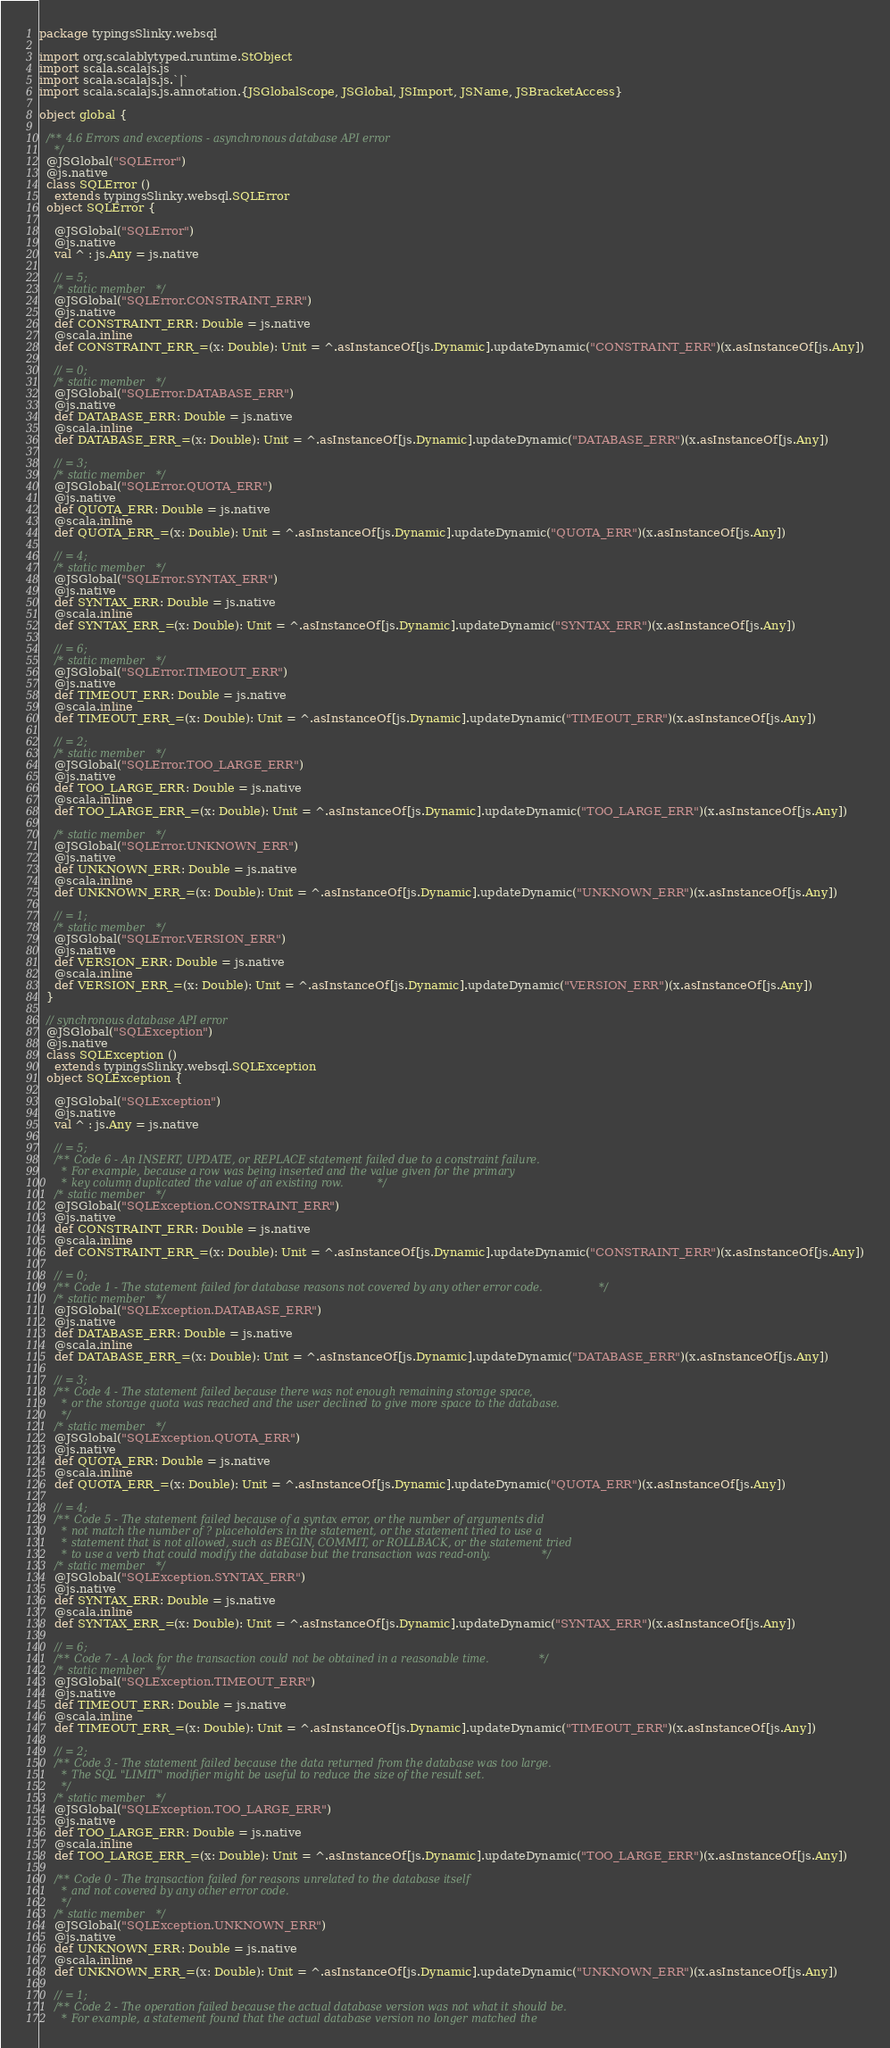Convert code to text. <code><loc_0><loc_0><loc_500><loc_500><_Scala_>package typingsSlinky.websql

import org.scalablytyped.runtime.StObject
import scala.scalajs.js
import scala.scalajs.js.`|`
import scala.scalajs.js.annotation.{JSGlobalScope, JSGlobal, JSImport, JSName, JSBracketAccess}

object global {
  
  /** 4.6 Errors and exceptions - asynchronous database API error
    */
  @JSGlobal("SQLError")
  @js.native
  class SQLError ()
    extends typingsSlinky.websql.SQLError
  object SQLError {
    
    @JSGlobal("SQLError")
    @js.native
    val ^ : js.Any = js.native
    
    // = 5;
    /* static member */
    @JSGlobal("SQLError.CONSTRAINT_ERR")
    @js.native
    def CONSTRAINT_ERR: Double = js.native
    @scala.inline
    def CONSTRAINT_ERR_=(x: Double): Unit = ^.asInstanceOf[js.Dynamic].updateDynamic("CONSTRAINT_ERR")(x.asInstanceOf[js.Any])
    
    // = 0;
    /* static member */
    @JSGlobal("SQLError.DATABASE_ERR")
    @js.native
    def DATABASE_ERR: Double = js.native
    @scala.inline
    def DATABASE_ERR_=(x: Double): Unit = ^.asInstanceOf[js.Dynamic].updateDynamic("DATABASE_ERR")(x.asInstanceOf[js.Any])
    
    // = 3;
    /* static member */
    @JSGlobal("SQLError.QUOTA_ERR")
    @js.native
    def QUOTA_ERR: Double = js.native
    @scala.inline
    def QUOTA_ERR_=(x: Double): Unit = ^.asInstanceOf[js.Dynamic].updateDynamic("QUOTA_ERR")(x.asInstanceOf[js.Any])
    
    // = 4;
    /* static member */
    @JSGlobal("SQLError.SYNTAX_ERR")
    @js.native
    def SYNTAX_ERR: Double = js.native
    @scala.inline
    def SYNTAX_ERR_=(x: Double): Unit = ^.asInstanceOf[js.Dynamic].updateDynamic("SYNTAX_ERR")(x.asInstanceOf[js.Any])
    
    // = 6;
    /* static member */
    @JSGlobal("SQLError.TIMEOUT_ERR")
    @js.native
    def TIMEOUT_ERR: Double = js.native
    @scala.inline
    def TIMEOUT_ERR_=(x: Double): Unit = ^.asInstanceOf[js.Dynamic].updateDynamic("TIMEOUT_ERR")(x.asInstanceOf[js.Any])
    
    // = 2;
    /* static member */
    @JSGlobal("SQLError.TOO_LARGE_ERR")
    @js.native
    def TOO_LARGE_ERR: Double = js.native
    @scala.inline
    def TOO_LARGE_ERR_=(x: Double): Unit = ^.asInstanceOf[js.Dynamic].updateDynamic("TOO_LARGE_ERR")(x.asInstanceOf[js.Any])
    
    /* static member */
    @JSGlobal("SQLError.UNKNOWN_ERR")
    @js.native
    def UNKNOWN_ERR: Double = js.native
    @scala.inline
    def UNKNOWN_ERR_=(x: Double): Unit = ^.asInstanceOf[js.Dynamic].updateDynamic("UNKNOWN_ERR")(x.asInstanceOf[js.Any])
    
    // = 1;
    /* static member */
    @JSGlobal("SQLError.VERSION_ERR")
    @js.native
    def VERSION_ERR: Double = js.native
    @scala.inline
    def VERSION_ERR_=(x: Double): Unit = ^.asInstanceOf[js.Dynamic].updateDynamic("VERSION_ERR")(x.asInstanceOf[js.Any])
  }
  
  // synchronous database API error
  @JSGlobal("SQLException")
  @js.native
  class SQLException ()
    extends typingsSlinky.websql.SQLException
  object SQLException {
    
    @JSGlobal("SQLException")
    @js.native
    val ^ : js.Any = js.native
    
    // = 5;
    /** Code 6 - An INSERT, UPDATE, or REPLACE statement failed due to a constraint failure.
      * For example, because a row was being inserted and the value given for the primary
      * key column duplicated the value of an existing row. */
    /* static member */
    @JSGlobal("SQLException.CONSTRAINT_ERR")
    @js.native
    def CONSTRAINT_ERR: Double = js.native
    @scala.inline
    def CONSTRAINT_ERR_=(x: Double): Unit = ^.asInstanceOf[js.Dynamic].updateDynamic("CONSTRAINT_ERR")(x.asInstanceOf[js.Any])
    
    // = 0;
    /** Code 1 - The statement failed for database reasons not covered by any other error code. */
    /* static member */
    @JSGlobal("SQLException.DATABASE_ERR")
    @js.native
    def DATABASE_ERR: Double = js.native
    @scala.inline
    def DATABASE_ERR_=(x: Double): Unit = ^.asInstanceOf[js.Dynamic].updateDynamic("DATABASE_ERR")(x.asInstanceOf[js.Any])
    
    // = 3;
    /** Code 4 - The statement failed because there was not enough remaining storage space,
      * or the storage quota was reached and the user declined to give more space to the database.
      */
    /* static member */
    @JSGlobal("SQLException.QUOTA_ERR")
    @js.native
    def QUOTA_ERR: Double = js.native
    @scala.inline
    def QUOTA_ERR_=(x: Double): Unit = ^.asInstanceOf[js.Dynamic].updateDynamic("QUOTA_ERR")(x.asInstanceOf[js.Any])
    
    // = 4;
    /** Code 5 - The statement failed because of a syntax error, or the number of arguments did
      * not match the number of ? placeholders in the statement, or the statement tried to use a
      * statement that is not allowed, such as BEGIN, COMMIT, or ROLLBACK, or the statement tried
      * to use a verb that could modify the database but the transaction was read-only. */
    /* static member */
    @JSGlobal("SQLException.SYNTAX_ERR")
    @js.native
    def SYNTAX_ERR: Double = js.native
    @scala.inline
    def SYNTAX_ERR_=(x: Double): Unit = ^.asInstanceOf[js.Dynamic].updateDynamic("SYNTAX_ERR")(x.asInstanceOf[js.Any])
    
    // = 6;
    /** Code 7 - A lock for the transaction could not be obtained in a reasonable time. */
    /* static member */
    @JSGlobal("SQLException.TIMEOUT_ERR")
    @js.native
    def TIMEOUT_ERR: Double = js.native
    @scala.inline
    def TIMEOUT_ERR_=(x: Double): Unit = ^.asInstanceOf[js.Dynamic].updateDynamic("TIMEOUT_ERR")(x.asInstanceOf[js.Any])
    
    // = 2;
    /** Code 3 - The statement failed because the data returned from the database was too large.
      * The SQL "LIMIT" modifier might be useful to reduce the size of the result set.
      */
    /* static member */
    @JSGlobal("SQLException.TOO_LARGE_ERR")
    @js.native
    def TOO_LARGE_ERR: Double = js.native
    @scala.inline
    def TOO_LARGE_ERR_=(x: Double): Unit = ^.asInstanceOf[js.Dynamic].updateDynamic("TOO_LARGE_ERR")(x.asInstanceOf[js.Any])
    
    /** Code 0 - The transaction failed for reasons unrelated to the database itself
      * and not covered by any other error code.
      */
    /* static member */
    @JSGlobal("SQLException.UNKNOWN_ERR")
    @js.native
    def UNKNOWN_ERR: Double = js.native
    @scala.inline
    def UNKNOWN_ERR_=(x: Double): Unit = ^.asInstanceOf[js.Dynamic].updateDynamic("UNKNOWN_ERR")(x.asInstanceOf[js.Any])
    
    // = 1;
    /** Code 2 - The operation failed because the actual database version was not what it should be.
      * For example, a statement found that the actual database version no longer matched the</code> 